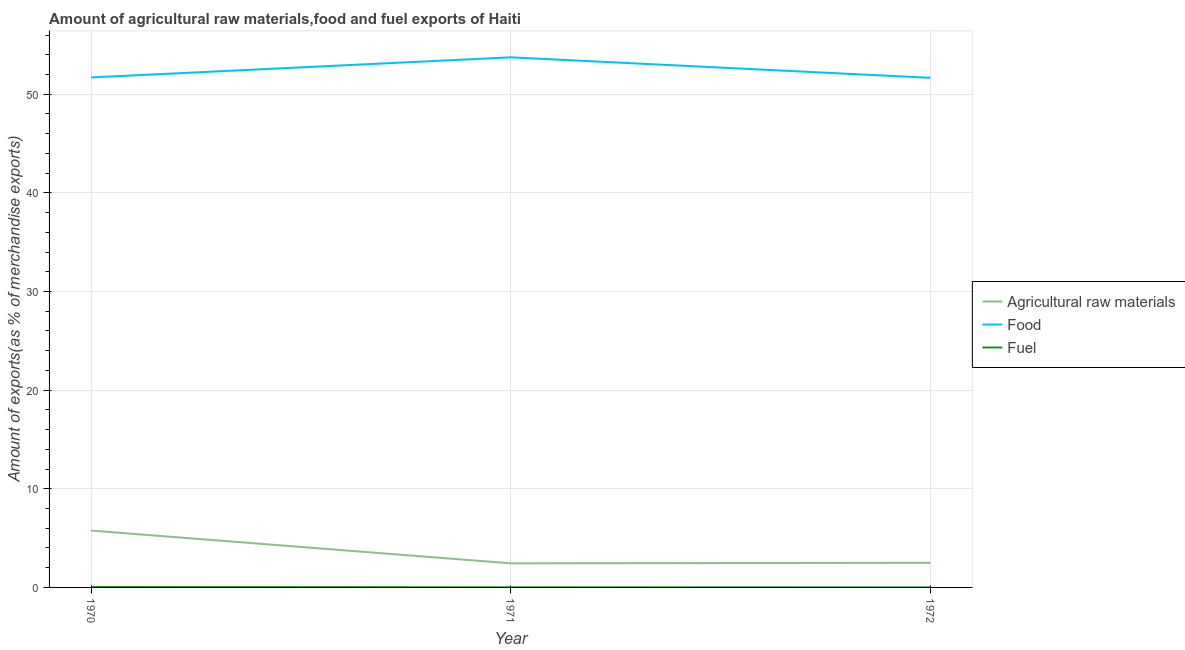How many different coloured lines are there?
Ensure brevity in your answer.  3. Does the line corresponding to percentage of raw materials exports intersect with the line corresponding to percentage of fuel exports?
Offer a terse response. No. Is the number of lines equal to the number of legend labels?
Offer a terse response. Yes. What is the percentage of food exports in 1970?
Provide a short and direct response. 51.71. Across all years, what is the maximum percentage of raw materials exports?
Give a very brief answer. 5.76. Across all years, what is the minimum percentage of fuel exports?
Your response must be concise. 1.15759498066816e-5. In which year was the percentage of food exports maximum?
Your answer should be compact. 1971. What is the total percentage of food exports in the graph?
Offer a very short reply. 157.11. What is the difference between the percentage of raw materials exports in 1970 and that in 1971?
Give a very brief answer. 3.32. What is the difference between the percentage of food exports in 1971 and the percentage of fuel exports in 1972?
Offer a very short reply. 53.74. What is the average percentage of fuel exports per year?
Provide a succinct answer. 0.02. In the year 1971, what is the difference between the percentage of raw materials exports and percentage of food exports?
Your answer should be compact. -51.3. In how many years, is the percentage of fuel exports greater than 32 %?
Make the answer very short. 0. What is the ratio of the percentage of fuel exports in 1970 to that in 1972?
Offer a terse response. 3831.78. Is the percentage of food exports in 1970 less than that in 1971?
Your response must be concise. Yes. Is the difference between the percentage of raw materials exports in 1971 and 1972 greater than the difference between the percentage of fuel exports in 1971 and 1972?
Provide a succinct answer. No. What is the difference between the highest and the second highest percentage of fuel exports?
Offer a terse response. 0.03. What is the difference between the highest and the lowest percentage of food exports?
Offer a very short reply. 2.08. Is the sum of the percentage of raw materials exports in 1970 and 1972 greater than the maximum percentage of fuel exports across all years?
Make the answer very short. Yes. Is it the case that in every year, the sum of the percentage of raw materials exports and percentage of food exports is greater than the percentage of fuel exports?
Your response must be concise. Yes. Does the percentage of fuel exports monotonically increase over the years?
Offer a terse response. No. Is the percentage of fuel exports strictly greater than the percentage of food exports over the years?
Give a very brief answer. No. Are the values on the major ticks of Y-axis written in scientific E-notation?
Make the answer very short. No. Where does the legend appear in the graph?
Give a very brief answer. Center right. How many legend labels are there?
Provide a short and direct response. 3. How are the legend labels stacked?
Offer a very short reply. Vertical. What is the title of the graph?
Offer a very short reply. Amount of agricultural raw materials,food and fuel exports of Haiti. Does "Fuel" appear as one of the legend labels in the graph?
Offer a very short reply. Yes. What is the label or title of the Y-axis?
Give a very brief answer. Amount of exports(as % of merchandise exports). What is the Amount of exports(as % of merchandise exports) in Agricultural raw materials in 1970?
Your answer should be compact. 5.76. What is the Amount of exports(as % of merchandise exports) of Food in 1970?
Provide a succinct answer. 51.71. What is the Amount of exports(as % of merchandise exports) of Fuel in 1970?
Offer a very short reply. 0.04. What is the Amount of exports(as % of merchandise exports) in Agricultural raw materials in 1971?
Provide a succinct answer. 2.44. What is the Amount of exports(as % of merchandise exports) in Food in 1971?
Give a very brief answer. 53.74. What is the Amount of exports(as % of merchandise exports) in Fuel in 1971?
Offer a very short reply. 0.01. What is the Amount of exports(as % of merchandise exports) in Agricultural raw materials in 1972?
Provide a short and direct response. 2.49. What is the Amount of exports(as % of merchandise exports) in Food in 1972?
Provide a succinct answer. 51.66. What is the Amount of exports(as % of merchandise exports) in Fuel in 1972?
Make the answer very short. 1.15759498066816e-5. Across all years, what is the maximum Amount of exports(as % of merchandise exports) in Agricultural raw materials?
Give a very brief answer. 5.76. Across all years, what is the maximum Amount of exports(as % of merchandise exports) of Food?
Provide a succinct answer. 53.74. Across all years, what is the maximum Amount of exports(as % of merchandise exports) in Fuel?
Provide a succinct answer. 0.04. Across all years, what is the minimum Amount of exports(as % of merchandise exports) of Agricultural raw materials?
Provide a succinct answer. 2.44. Across all years, what is the minimum Amount of exports(as % of merchandise exports) in Food?
Provide a short and direct response. 51.66. Across all years, what is the minimum Amount of exports(as % of merchandise exports) in Fuel?
Offer a terse response. 1.15759498066816e-5. What is the total Amount of exports(as % of merchandise exports) of Agricultural raw materials in the graph?
Provide a succinct answer. 10.7. What is the total Amount of exports(as % of merchandise exports) of Food in the graph?
Make the answer very short. 157.11. What is the total Amount of exports(as % of merchandise exports) in Fuel in the graph?
Your response must be concise. 0.06. What is the difference between the Amount of exports(as % of merchandise exports) of Agricultural raw materials in 1970 and that in 1971?
Give a very brief answer. 3.32. What is the difference between the Amount of exports(as % of merchandise exports) in Food in 1970 and that in 1971?
Make the answer very short. -2.04. What is the difference between the Amount of exports(as % of merchandise exports) of Agricultural raw materials in 1970 and that in 1972?
Provide a short and direct response. 3.27. What is the difference between the Amount of exports(as % of merchandise exports) in Food in 1970 and that in 1972?
Your answer should be compact. 0.04. What is the difference between the Amount of exports(as % of merchandise exports) in Fuel in 1970 and that in 1972?
Offer a very short reply. 0.04. What is the difference between the Amount of exports(as % of merchandise exports) of Agricultural raw materials in 1971 and that in 1972?
Your answer should be very brief. -0.05. What is the difference between the Amount of exports(as % of merchandise exports) of Food in 1971 and that in 1972?
Provide a short and direct response. 2.08. What is the difference between the Amount of exports(as % of merchandise exports) in Fuel in 1971 and that in 1972?
Offer a very short reply. 0.01. What is the difference between the Amount of exports(as % of merchandise exports) in Agricultural raw materials in 1970 and the Amount of exports(as % of merchandise exports) in Food in 1971?
Your answer should be very brief. -47.98. What is the difference between the Amount of exports(as % of merchandise exports) in Agricultural raw materials in 1970 and the Amount of exports(as % of merchandise exports) in Fuel in 1971?
Ensure brevity in your answer.  5.75. What is the difference between the Amount of exports(as % of merchandise exports) in Food in 1970 and the Amount of exports(as % of merchandise exports) in Fuel in 1971?
Your answer should be compact. 51.7. What is the difference between the Amount of exports(as % of merchandise exports) of Agricultural raw materials in 1970 and the Amount of exports(as % of merchandise exports) of Food in 1972?
Your response must be concise. -45.9. What is the difference between the Amount of exports(as % of merchandise exports) of Agricultural raw materials in 1970 and the Amount of exports(as % of merchandise exports) of Fuel in 1972?
Provide a succinct answer. 5.76. What is the difference between the Amount of exports(as % of merchandise exports) of Food in 1970 and the Amount of exports(as % of merchandise exports) of Fuel in 1972?
Offer a very short reply. 51.71. What is the difference between the Amount of exports(as % of merchandise exports) in Agricultural raw materials in 1971 and the Amount of exports(as % of merchandise exports) in Food in 1972?
Offer a terse response. -49.22. What is the difference between the Amount of exports(as % of merchandise exports) of Agricultural raw materials in 1971 and the Amount of exports(as % of merchandise exports) of Fuel in 1972?
Provide a short and direct response. 2.44. What is the difference between the Amount of exports(as % of merchandise exports) in Food in 1971 and the Amount of exports(as % of merchandise exports) in Fuel in 1972?
Ensure brevity in your answer.  53.74. What is the average Amount of exports(as % of merchandise exports) in Agricultural raw materials per year?
Offer a very short reply. 3.57. What is the average Amount of exports(as % of merchandise exports) of Food per year?
Your response must be concise. 52.37. What is the average Amount of exports(as % of merchandise exports) of Fuel per year?
Offer a terse response. 0.02. In the year 1970, what is the difference between the Amount of exports(as % of merchandise exports) in Agricultural raw materials and Amount of exports(as % of merchandise exports) in Food?
Your answer should be very brief. -45.94. In the year 1970, what is the difference between the Amount of exports(as % of merchandise exports) in Agricultural raw materials and Amount of exports(as % of merchandise exports) in Fuel?
Provide a succinct answer. 5.72. In the year 1970, what is the difference between the Amount of exports(as % of merchandise exports) in Food and Amount of exports(as % of merchandise exports) in Fuel?
Your answer should be very brief. 51.66. In the year 1971, what is the difference between the Amount of exports(as % of merchandise exports) in Agricultural raw materials and Amount of exports(as % of merchandise exports) in Food?
Make the answer very short. -51.3. In the year 1971, what is the difference between the Amount of exports(as % of merchandise exports) in Agricultural raw materials and Amount of exports(as % of merchandise exports) in Fuel?
Ensure brevity in your answer.  2.43. In the year 1971, what is the difference between the Amount of exports(as % of merchandise exports) of Food and Amount of exports(as % of merchandise exports) of Fuel?
Make the answer very short. 53.73. In the year 1972, what is the difference between the Amount of exports(as % of merchandise exports) in Agricultural raw materials and Amount of exports(as % of merchandise exports) in Food?
Make the answer very short. -49.17. In the year 1972, what is the difference between the Amount of exports(as % of merchandise exports) in Agricultural raw materials and Amount of exports(as % of merchandise exports) in Fuel?
Provide a short and direct response. 2.49. In the year 1972, what is the difference between the Amount of exports(as % of merchandise exports) in Food and Amount of exports(as % of merchandise exports) in Fuel?
Provide a succinct answer. 51.66. What is the ratio of the Amount of exports(as % of merchandise exports) of Agricultural raw materials in 1970 to that in 1971?
Make the answer very short. 2.36. What is the ratio of the Amount of exports(as % of merchandise exports) of Food in 1970 to that in 1971?
Your answer should be very brief. 0.96. What is the ratio of the Amount of exports(as % of merchandise exports) in Fuel in 1970 to that in 1971?
Ensure brevity in your answer.  4. What is the ratio of the Amount of exports(as % of merchandise exports) of Agricultural raw materials in 1970 to that in 1972?
Provide a succinct answer. 2.31. What is the ratio of the Amount of exports(as % of merchandise exports) of Food in 1970 to that in 1972?
Provide a succinct answer. 1. What is the ratio of the Amount of exports(as % of merchandise exports) in Fuel in 1970 to that in 1972?
Keep it short and to the point. 3831.78. What is the ratio of the Amount of exports(as % of merchandise exports) of Agricultural raw materials in 1971 to that in 1972?
Offer a terse response. 0.98. What is the ratio of the Amount of exports(as % of merchandise exports) in Food in 1971 to that in 1972?
Make the answer very short. 1.04. What is the ratio of the Amount of exports(as % of merchandise exports) of Fuel in 1971 to that in 1972?
Your answer should be compact. 957.84. What is the difference between the highest and the second highest Amount of exports(as % of merchandise exports) of Agricultural raw materials?
Your answer should be compact. 3.27. What is the difference between the highest and the second highest Amount of exports(as % of merchandise exports) in Food?
Your answer should be very brief. 2.04. What is the difference between the highest and the second highest Amount of exports(as % of merchandise exports) of Fuel?
Ensure brevity in your answer.  0.03. What is the difference between the highest and the lowest Amount of exports(as % of merchandise exports) in Agricultural raw materials?
Your response must be concise. 3.32. What is the difference between the highest and the lowest Amount of exports(as % of merchandise exports) of Food?
Provide a succinct answer. 2.08. What is the difference between the highest and the lowest Amount of exports(as % of merchandise exports) in Fuel?
Ensure brevity in your answer.  0.04. 